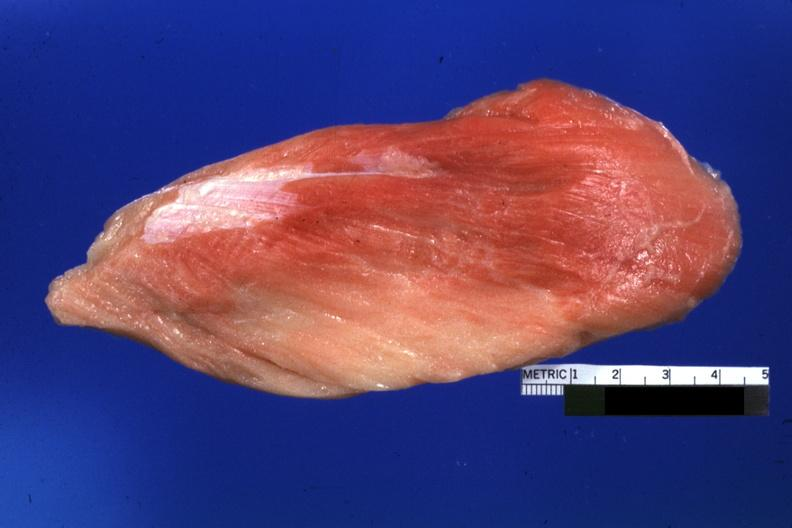s myelomonocytic leukemia present?
Answer the question using a single word or phrase. No 